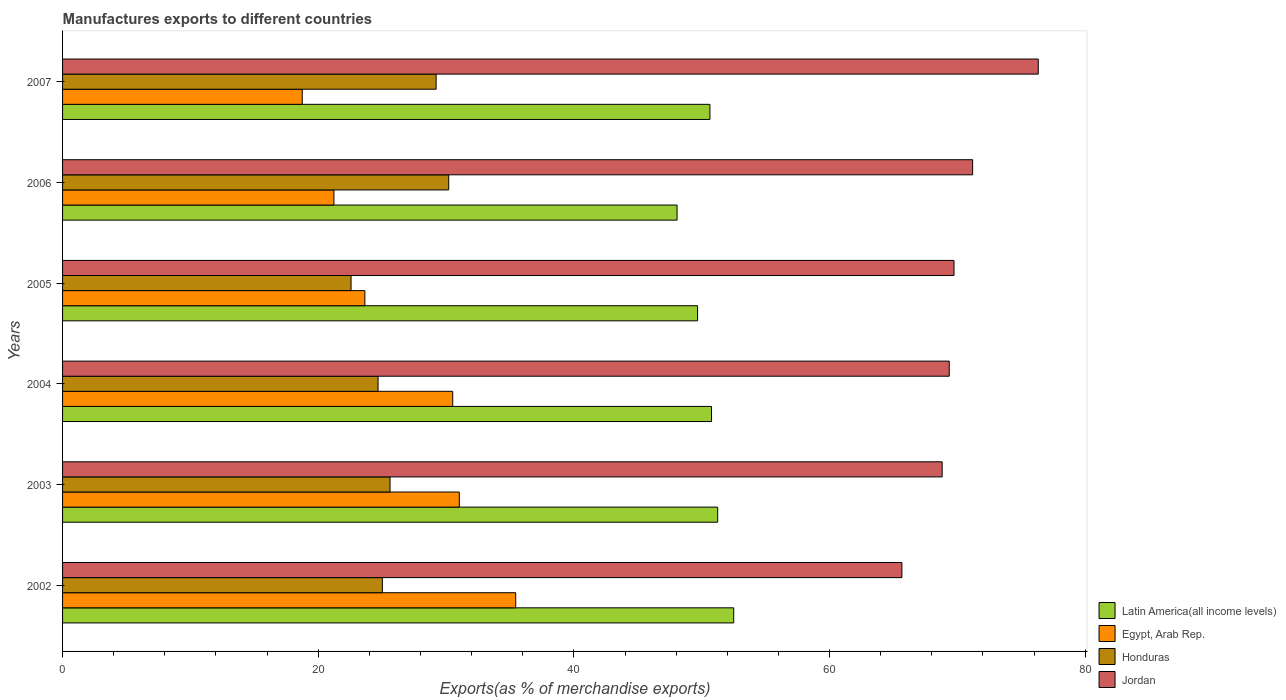Are the number of bars on each tick of the Y-axis equal?
Make the answer very short. Yes. What is the label of the 3rd group of bars from the top?
Provide a succinct answer. 2005. In how many cases, is the number of bars for a given year not equal to the number of legend labels?
Provide a succinct answer. 0. What is the percentage of exports to different countries in Jordan in 2006?
Offer a terse response. 71.19. Across all years, what is the maximum percentage of exports to different countries in Jordan?
Offer a terse response. 76.33. Across all years, what is the minimum percentage of exports to different countries in Latin America(all income levels)?
Your answer should be very brief. 48.07. In which year was the percentage of exports to different countries in Honduras maximum?
Ensure brevity in your answer.  2006. What is the total percentage of exports to different countries in Jordan in the graph?
Make the answer very short. 421.08. What is the difference between the percentage of exports to different countries in Honduras in 2002 and that in 2007?
Ensure brevity in your answer.  -4.2. What is the difference between the percentage of exports to different countries in Egypt, Arab Rep. in 2004 and the percentage of exports to different countries in Honduras in 2006?
Ensure brevity in your answer.  0.31. What is the average percentage of exports to different countries in Jordan per year?
Keep it short and to the point. 70.18. In the year 2007, what is the difference between the percentage of exports to different countries in Honduras and percentage of exports to different countries in Egypt, Arab Rep.?
Provide a succinct answer. 10.47. What is the ratio of the percentage of exports to different countries in Honduras in 2002 to that in 2004?
Make the answer very short. 1.01. What is the difference between the highest and the second highest percentage of exports to different countries in Latin America(all income levels)?
Give a very brief answer. 1.25. What is the difference between the highest and the lowest percentage of exports to different countries in Egypt, Arab Rep.?
Keep it short and to the point. 16.7. Is it the case that in every year, the sum of the percentage of exports to different countries in Honduras and percentage of exports to different countries in Egypt, Arab Rep. is greater than the sum of percentage of exports to different countries in Latin America(all income levels) and percentage of exports to different countries in Jordan?
Offer a very short reply. No. What does the 4th bar from the top in 2003 represents?
Provide a succinct answer. Latin America(all income levels). What does the 3rd bar from the bottom in 2003 represents?
Your response must be concise. Honduras. Is it the case that in every year, the sum of the percentage of exports to different countries in Honduras and percentage of exports to different countries in Egypt, Arab Rep. is greater than the percentage of exports to different countries in Latin America(all income levels)?
Your answer should be very brief. No. How many bars are there?
Your response must be concise. 24. Are the values on the major ticks of X-axis written in scientific E-notation?
Ensure brevity in your answer.  No. Does the graph contain any zero values?
Offer a very short reply. No. Does the graph contain grids?
Provide a short and direct response. No. How are the legend labels stacked?
Ensure brevity in your answer.  Vertical. What is the title of the graph?
Your response must be concise. Manufactures exports to different countries. What is the label or title of the X-axis?
Give a very brief answer. Exports(as % of merchandise exports). What is the Exports(as % of merchandise exports) of Latin America(all income levels) in 2002?
Provide a succinct answer. 52.5. What is the Exports(as % of merchandise exports) of Egypt, Arab Rep. in 2002?
Provide a short and direct response. 35.45. What is the Exports(as % of merchandise exports) of Honduras in 2002?
Your response must be concise. 25.02. What is the Exports(as % of merchandise exports) of Jordan in 2002?
Provide a succinct answer. 65.66. What is the Exports(as % of merchandise exports) in Latin America(all income levels) in 2003?
Your answer should be very brief. 51.25. What is the Exports(as % of merchandise exports) of Egypt, Arab Rep. in 2003?
Your answer should be compact. 31.04. What is the Exports(as % of merchandise exports) in Honduras in 2003?
Offer a terse response. 25.62. What is the Exports(as % of merchandise exports) in Jordan in 2003?
Your response must be concise. 68.81. What is the Exports(as % of merchandise exports) in Latin America(all income levels) in 2004?
Your answer should be compact. 50.77. What is the Exports(as % of merchandise exports) of Egypt, Arab Rep. in 2004?
Your response must be concise. 30.52. What is the Exports(as % of merchandise exports) in Honduras in 2004?
Ensure brevity in your answer.  24.68. What is the Exports(as % of merchandise exports) of Jordan in 2004?
Your answer should be very brief. 69.36. What is the Exports(as % of merchandise exports) in Latin America(all income levels) in 2005?
Offer a terse response. 49.68. What is the Exports(as % of merchandise exports) of Egypt, Arab Rep. in 2005?
Your answer should be compact. 23.65. What is the Exports(as % of merchandise exports) in Honduras in 2005?
Make the answer very short. 22.57. What is the Exports(as % of merchandise exports) of Jordan in 2005?
Provide a short and direct response. 69.73. What is the Exports(as % of merchandise exports) of Latin America(all income levels) in 2006?
Offer a terse response. 48.07. What is the Exports(as % of merchandise exports) in Egypt, Arab Rep. in 2006?
Your answer should be very brief. 21.23. What is the Exports(as % of merchandise exports) in Honduras in 2006?
Ensure brevity in your answer.  30.21. What is the Exports(as % of merchandise exports) in Jordan in 2006?
Keep it short and to the point. 71.19. What is the Exports(as % of merchandise exports) in Latin America(all income levels) in 2007?
Provide a short and direct response. 50.64. What is the Exports(as % of merchandise exports) in Egypt, Arab Rep. in 2007?
Provide a succinct answer. 18.75. What is the Exports(as % of merchandise exports) of Honduras in 2007?
Your answer should be very brief. 29.22. What is the Exports(as % of merchandise exports) in Jordan in 2007?
Offer a very short reply. 76.33. Across all years, what is the maximum Exports(as % of merchandise exports) in Latin America(all income levels)?
Keep it short and to the point. 52.5. Across all years, what is the maximum Exports(as % of merchandise exports) in Egypt, Arab Rep.?
Your answer should be very brief. 35.45. Across all years, what is the maximum Exports(as % of merchandise exports) in Honduras?
Provide a succinct answer. 30.21. Across all years, what is the maximum Exports(as % of merchandise exports) of Jordan?
Provide a succinct answer. 76.33. Across all years, what is the minimum Exports(as % of merchandise exports) of Latin America(all income levels)?
Give a very brief answer. 48.07. Across all years, what is the minimum Exports(as % of merchandise exports) of Egypt, Arab Rep.?
Provide a short and direct response. 18.75. Across all years, what is the minimum Exports(as % of merchandise exports) in Honduras?
Your response must be concise. 22.57. Across all years, what is the minimum Exports(as % of merchandise exports) in Jordan?
Provide a succinct answer. 65.66. What is the total Exports(as % of merchandise exports) in Latin America(all income levels) in the graph?
Ensure brevity in your answer.  302.9. What is the total Exports(as % of merchandise exports) of Egypt, Arab Rep. in the graph?
Keep it short and to the point. 160.63. What is the total Exports(as % of merchandise exports) of Honduras in the graph?
Your answer should be very brief. 157.31. What is the total Exports(as % of merchandise exports) of Jordan in the graph?
Make the answer very short. 421.08. What is the difference between the Exports(as % of merchandise exports) in Latin America(all income levels) in 2002 and that in 2003?
Make the answer very short. 1.25. What is the difference between the Exports(as % of merchandise exports) in Egypt, Arab Rep. in 2002 and that in 2003?
Provide a succinct answer. 4.41. What is the difference between the Exports(as % of merchandise exports) of Honduras in 2002 and that in 2003?
Your answer should be compact. -0.6. What is the difference between the Exports(as % of merchandise exports) of Jordan in 2002 and that in 2003?
Offer a terse response. -3.15. What is the difference between the Exports(as % of merchandise exports) of Latin America(all income levels) in 2002 and that in 2004?
Your response must be concise. 1.74. What is the difference between the Exports(as % of merchandise exports) of Egypt, Arab Rep. in 2002 and that in 2004?
Keep it short and to the point. 4.93. What is the difference between the Exports(as % of merchandise exports) in Honduras in 2002 and that in 2004?
Make the answer very short. 0.34. What is the difference between the Exports(as % of merchandise exports) of Jordan in 2002 and that in 2004?
Give a very brief answer. -3.7. What is the difference between the Exports(as % of merchandise exports) in Latin America(all income levels) in 2002 and that in 2005?
Provide a succinct answer. 2.83. What is the difference between the Exports(as % of merchandise exports) of Egypt, Arab Rep. in 2002 and that in 2005?
Your response must be concise. 11.8. What is the difference between the Exports(as % of merchandise exports) of Honduras in 2002 and that in 2005?
Provide a short and direct response. 2.45. What is the difference between the Exports(as % of merchandise exports) of Jordan in 2002 and that in 2005?
Offer a terse response. -4.08. What is the difference between the Exports(as % of merchandise exports) in Latin America(all income levels) in 2002 and that in 2006?
Give a very brief answer. 4.43. What is the difference between the Exports(as % of merchandise exports) of Egypt, Arab Rep. in 2002 and that in 2006?
Give a very brief answer. 14.22. What is the difference between the Exports(as % of merchandise exports) of Honduras in 2002 and that in 2006?
Ensure brevity in your answer.  -5.19. What is the difference between the Exports(as % of merchandise exports) in Jordan in 2002 and that in 2006?
Offer a very short reply. -5.53. What is the difference between the Exports(as % of merchandise exports) in Latin America(all income levels) in 2002 and that in 2007?
Offer a terse response. 1.86. What is the difference between the Exports(as % of merchandise exports) in Egypt, Arab Rep. in 2002 and that in 2007?
Offer a very short reply. 16.7. What is the difference between the Exports(as % of merchandise exports) of Honduras in 2002 and that in 2007?
Provide a succinct answer. -4.2. What is the difference between the Exports(as % of merchandise exports) of Jordan in 2002 and that in 2007?
Keep it short and to the point. -10.67. What is the difference between the Exports(as % of merchandise exports) of Latin America(all income levels) in 2003 and that in 2004?
Keep it short and to the point. 0.48. What is the difference between the Exports(as % of merchandise exports) in Egypt, Arab Rep. in 2003 and that in 2004?
Offer a very short reply. 0.52. What is the difference between the Exports(as % of merchandise exports) of Honduras in 2003 and that in 2004?
Offer a very short reply. 0.94. What is the difference between the Exports(as % of merchandise exports) of Jordan in 2003 and that in 2004?
Provide a short and direct response. -0.55. What is the difference between the Exports(as % of merchandise exports) of Latin America(all income levels) in 2003 and that in 2005?
Your response must be concise. 1.57. What is the difference between the Exports(as % of merchandise exports) of Egypt, Arab Rep. in 2003 and that in 2005?
Your response must be concise. 7.39. What is the difference between the Exports(as % of merchandise exports) in Honduras in 2003 and that in 2005?
Keep it short and to the point. 3.05. What is the difference between the Exports(as % of merchandise exports) in Jordan in 2003 and that in 2005?
Your response must be concise. -0.93. What is the difference between the Exports(as % of merchandise exports) in Latin America(all income levels) in 2003 and that in 2006?
Keep it short and to the point. 3.18. What is the difference between the Exports(as % of merchandise exports) in Egypt, Arab Rep. in 2003 and that in 2006?
Keep it short and to the point. 9.81. What is the difference between the Exports(as % of merchandise exports) in Honduras in 2003 and that in 2006?
Your answer should be compact. -4.59. What is the difference between the Exports(as % of merchandise exports) in Jordan in 2003 and that in 2006?
Give a very brief answer. -2.38. What is the difference between the Exports(as % of merchandise exports) in Latin America(all income levels) in 2003 and that in 2007?
Provide a succinct answer. 0.61. What is the difference between the Exports(as % of merchandise exports) in Egypt, Arab Rep. in 2003 and that in 2007?
Offer a very short reply. 12.29. What is the difference between the Exports(as % of merchandise exports) of Honduras in 2003 and that in 2007?
Offer a very short reply. -3.6. What is the difference between the Exports(as % of merchandise exports) in Jordan in 2003 and that in 2007?
Ensure brevity in your answer.  -7.52. What is the difference between the Exports(as % of merchandise exports) in Latin America(all income levels) in 2004 and that in 2005?
Offer a terse response. 1.09. What is the difference between the Exports(as % of merchandise exports) of Egypt, Arab Rep. in 2004 and that in 2005?
Your answer should be compact. 6.87. What is the difference between the Exports(as % of merchandise exports) in Honduras in 2004 and that in 2005?
Offer a terse response. 2.11. What is the difference between the Exports(as % of merchandise exports) in Jordan in 2004 and that in 2005?
Offer a very short reply. -0.37. What is the difference between the Exports(as % of merchandise exports) of Latin America(all income levels) in 2004 and that in 2006?
Give a very brief answer. 2.7. What is the difference between the Exports(as % of merchandise exports) in Egypt, Arab Rep. in 2004 and that in 2006?
Provide a succinct answer. 9.29. What is the difference between the Exports(as % of merchandise exports) in Honduras in 2004 and that in 2006?
Your response must be concise. -5.53. What is the difference between the Exports(as % of merchandise exports) in Jordan in 2004 and that in 2006?
Make the answer very short. -1.83. What is the difference between the Exports(as % of merchandise exports) in Latin America(all income levels) in 2004 and that in 2007?
Make the answer very short. 0.13. What is the difference between the Exports(as % of merchandise exports) in Egypt, Arab Rep. in 2004 and that in 2007?
Make the answer very short. 11.77. What is the difference between the Exports(as % of merchandise exports) in Honduras in 2004 and that in 2007?
Keep it short and to the point. -4.54. What is the difference between the Exports(as % of merchandise exports) of Jordan in 2004 and that in 2007?
Keep it short and to the point. -6.96. What is the difference between the Exports(as % of merchandise exports) of Latin America(all income levels) in 2005 and that in 2006?
Keep it short and to the point. 1.6. What is the difference between the Exports(as % of merchandise exports) of Egypt, Arab Rep. in 2005 and that in 2006?
Your answer should be compact. 2.42. What is the difference between the Exports(as % of merchandise exports) in Honduras in 2005 and that in 2006?
Ensure brevity in your answer.  -7.64. What is the difference between the Exports(as % of merchandise exports) in Jordan in 2005 and that in 2006?
Offer a very short reply. -1.46. What is the difference between the Exports(as % of merchandise exports) of Latin America(all income levels) in 2005 and that in 2007?
Your response must be concise. -0.97. What is the difference between the Exports(as % of merchandise exports) in Egypt, Arab Rep. in 2005 and that in 2007?
Offer a very short reply. 4.9. What is the difference between the Exports(as % of merchandise exports) of Honduras in 2005 and that in 2007?
Keep it short and to the point. -6.65. What is the difference between the Exports(as % of merchandise exports) of Jordan in 2005 and that in 2007?
Offer a very short reply. -6.59. What is the difference between the Exports(as % of merchandise exports) of Latin America(all income levels) in 2006 and that in 2007?
Give a very brief answer. -2.57. What is the difference between the Exports(as % of merchandise exports) in Egypt, Arab Rep. in 2006 and that in 2007?
Ensure brevity in your answer.  2.48. What is the difference between the Exports(as % of merchandise exports) in Honduras in 2006 and that in 2007?
Your answer should be compact. 0.99. What is the difference between the Exports(as % of merchandise exports) of Jordan in 2006 and that in 2007?
Your answer should be very brief. -5.13. What is the difference between the Exports(as % of merchandise exports) of Latin America(all income levels) in 2002 and the Exports(as % of merchandise exports) of Egypt, Arab Rep. in 2003?
Your answer should be very brief. 21.47. What is the difference between the Exports(as % of merchandise exports) in Latin America(all income levels) in 2002 and the Exports(as % of merchandise exports) in Honduras in 2003?
Provide a succinct answer. 26.88. What is the difference between the Exports(as % of merchandise exports) in Latin America(all income levels) in 2002 and the Exports(as % of merchandise exports) in Jordan in 2003?
Give a very brief answer. -16.31. What is the difference between the Exports(as % of merchandise exports) in Egypt, Arab Rep. in 2002 and the Exports(as % of merchandise exports) in Honduras in 2003?
Make the answer very short. 9.83. What is the difference between the Exports(as % of merchandise exports) in Egypt, Arab Rep. in 2002 and the Exports(as % of merchandise exports) in Jordan in 2003?
Offer a very short reply. -33.36. What is the difference between the Exports(as % of merchandise exports) in Honduras in 2002 and the Exports(as % of merchandise exports) in Jordan in 2003?
Give a very brief answer. -43.79. What is the difference between the Exports(as % of merchandise exports) of Latin America(all income levels) in 2002 and the Exports(as % of merchandise exports) of Egypt, Arab Rep. in 2004?
Give a very brief answer. 21.98. What is the difference between the Exports(as % of merchandise exports) of Latin America(all income levels) in 2002 and the Exports(as % of merchandise exports) of Honduras in 2004?
Your answer should be compact. 27.82. What is the difference between the Exports(as % of merchandise exports) of Latin America(all income levels) in 2002 and the Exports(as % of merchandise exports) of Jordan in 2004?
Your response must be concise. -16.86. What is the difference between the Exports(as % of merchandise exports) of Egypt, Arab Rep. in 2002 and the Exports(as % of merchandise exports) of Honduras in 2004?
Ensure brevity in your answer.  10.77. What is the difference between the Exports(as % of merchandise exports) of Egypt, Arab Rep. in 2002 and the Exports(as % of merchandise exports) of Jordan in 2004?
Make the answer very short. -33.91. What is the difference between the Exports(as % of merchandise exports) in Honduras in 2002 and the Exports(as % of merchandise exports) in Jordan in 2004?
Ensure brevity in your answer.  -44.34. What is the difference between the Exports(as % of merchandise exports) in Latin America(all income levels) in 2002 and the Exports(as % of merchandise exports) in Egypt, Arab Rep. in 2005?
Ensure brevity in your answer.  28.85. What is the difference between the Exports(as % of merchandise exports) of Latin America(all income levels) in 2002 and the Exports(as % of merchandise exports) of Honduras in 2005?
Make the answer very short. 29.93. What is the difference between the Exports(as % of merchandise exports) in Latin America(all income levels) in 2002 and the Exports(as % of merchandise exports) in Jordan in 2005?
Give a very brief answer. -17.23. What is the difference between the Exports(as % of merchandise exports) of Egypt, Arab Rep. in 2002 and the Exports(as % of merchandise exports) of Honduras in 2005?
Give a very brief answer. 12.88. What is the difference between the Exports(as % of merchandise exports) of Egypt, Arab Rep. in 2002 and the Exports(as % of merchandise exports) of Jordan in 2005?
Your response must be concise. -34.29. What is the difference between the Exports(as % of merchandise exports) of Honduras in 2002 and the Exports(as % of merchandise exports) of Jordan in 2005?
Provide a succinct answer. -44.72. What is the difference between the Exports(as % of merchandise exports) in Latin America(all income levels) in 2002 and the Exports(as % of merchandise exports) in Egypt, Arab Rep. in 2006?
Make the answer very short. 31.28. What is the difference between the Exports(as % of merchandise exports) in Latin America(all income levels) in 2002 and the Exports(as % of merchandise exports) in Honduras in 2006?
Keep it short and to the point. 22.3. What is the difference between the Exports(as % of merchandise exports) of Latin America(all income levels) in 2002 and the Exports(as % of merchandise exports) of Jordan in 2006?
Make the answer very short. -18.69. What is the difference between the Exports(as % of merchandise exports) in Egypt, Arab Rep. in 2002 and the Exports(as % of merchandise exports) in Honduras in 2006?
Give a very brief answer. 5.24. What is the difference between the Exports(as % of merchandise exports) in Egypt, Arab Rep. in 2002 and the Exports(as % of merchandise exports) in Jordan in 2006?
Provide a short and direct response. -35.74. What is the difference between the Exports(as % of merchandise exports) of Honduras in 2002 and the Exports(as % of merchandise exports) of Jordan in 2006?
Give a very brief answer. -46.17. What is the difference between the Exports(as % of merchandise exports) of Latin America(all income levels) in 2002 and the Exports(as % of merchandise exports) of Egypt, Arab Rep. in 2007?
Offer a terse response. 33.75. What is the difference between the Exports(as % of merchandise exports) of Latin America(all income levels) in 2002 and the Exports(as % of merchandise exports) of Honduras in 2007?
Ensure brevity in your answer.  23.28. What is the difference between the Exports(as % of merchandise exports) in Latin America(all income levels) in 2002 and the Exports(as % of merchandise exports) in Jordan in 2007?
Your answer should be very brief. -23.82. What is the difference between the Exports(as % of merchandise exports) in Egypt, Arab Rep. in 2002 and the Exports(as % of merchandise exports) in Honduras in 2007?
Provide a short and direct response. 6.23. What is the difference between the Exports(as % of merchandise exports) of Egypt, Arab Rep. in 2002 and the Exports(as % of merchandise exports) of Jordan in 2007?
Offer a very short reply. -40.88. What is the difference between the Exports(as % of merchandise exports) of Honduras in 2002 and the Exports(as % of merchandise exports) of Jordan in 2007?
Offer a very short reply. -51.31. What is the difference between the Exports(as % of merchandise exports) of Latin America(all income levels) in 2003 and the Exports(as % of merchandise exports) of Egypt, Arab Rep. in 2004?
Provide a short and direct response. 20.73. What is the difference between the Exports(as % of merchandise exports) in Latin America(all income levels) in 2003 and the Exports(as % of merchandise exports) in Honduras in 2004?
Provide a succinct answer. 26.57. What is the difference between the Exports(as % of merchandise exports) in Latin America(all income levels) in 2003 and the Exports(as % of merchandise exports) in Jordan in 2004?
Your answer should be very brief. -18.11. What is the difference between the Exports(as % of merchandise exports) in Egypt, Arab Rep. in 2003 and the Exports(as % of merchandise exports) in Honduras in 2004?
Provide a short and direct response. 6.36. What is the difference between the Exports(as % of merchandise exports) of Egypt, Arab Rep. in 2003 and the Exports(as % of merchandise exports) of Jordan in 2004?
Your answer should be very brief. -38.32. What is the difference between the Exports(as % of merchandise exports) of Honduras in 2003 and the Exports(as % of merchandise exports) of Jordan in 2004?
Ensure brevity in your answer.  -43.74. What is the difference between the Exports(as % of merchandise exports) of Latin America(all income levels) in 2003 and the Exports(as % of merchandise exports) of Egypt, Arab Rep. in 2005?
Give a very brief answer. 27.6. What is the difference between the Exports(as % of merchandise exports) in Latin America(all income levels) in 2003 and the Exports(as % of merchandise exports) in Honduras in 2005?
Your response must be concise. 28.68. What is the difference between the Exports(as % of merchandise exports) in Latin America(all income levels) in 2003 and the Exports(as % of merchandise exports) in Jordan in 2005?
Offer a very short reply. -18.49. What is the difference between the Exports(as % of merchandise exports) in Egypt, Arab Rep. in 2003 and the Exports(as % of merchandise exports) in Honduras in 2005?
Your response must be concise. 8.47. What is the difference between the Exports(as % of merchandise exports) of Egypt, Arab Rep. in 2003 and the Exports(as % of merchandise exports) of Jordan in 2005?
Provide a succinct answer. -38.7. What is the difference between the Exports(as % of merchandise exports) of Honduras in 2003 and the Exports(as % of merchandise exports) of Jordan in 2005?
Provide a short and direct response. -44.12. What is the difference between the Exports(as % of merchandise exports) in Latin America(all income levels) in 2003 and the Exports(as % of merchandise exports) in Egypt, Arab Rep. in 2006?
Give a very brief answer. 30.02. What is the difference between the Exports(as % of merchandise exports) in Latin America(all income levels) in 2003 and the Exports(as % of merchandise exports) in Honduras in 2006?
Give a very brief answer. 21.04. What is the difference between the Exports(as % of merchandise exports) in Latin America(all income levels) in 2003 and the Exports(as % of merchandise exports) in Jordan in 2006?
Offer a very short reply. -19.94. What is the difference between the Exports(as % of merchandise exports) in Egypt, Arab Rep. in 2003 and the Exports(as % of merchandise exports) in Honduras in 2006?
Make the answer very short. 0.83. What is the difference between the Exports(as % of merchandise exports) in Egypt, Arab Rep. in 2003 and the Exports(as % of merchandise exports) in Jordan in 2006?
Ensure brevity in your answer.  -40.15. What is the difference between the Exports(as % of merchandise exports) in Honduras in 2003 and the Exports(as % of merchandise exports) in Jordan in 2006?
Make the answer very short. -45.57. What is the difference between the Exports(as % of merchandise exports) of Latin America(all income levels) in 2003 and the Exports(as % of merchandise exports) of Egypt, Arab Rep. in 2007?
Ensure brevity in your answer.  32.5. What is the difference between the Exports(as % of merchandise exports) in Latin America(all income levels) in 2003 and the Exports(as % of merchandise exports) in Honduras in 2007?
Make the answer very short. 22.03. What is the difference between the Exports(as % of merchandise exports) in Latin America(all income levels) in 2003 and the Exports(as % of merchandise exports) in Jordan in 2007?
Your answer should be very brief. -25.08. What is the difference between the Exports(as % of merchandise exports) in Egypt, Arab Rep. in 2003 and the Exports(as % of merchandise exports) in Honduras in 2007?
Provide a short and direct response. 1.81. What is the difference between the Exports(as % of merchandise exports) of Egypt, Arab Rep. in 2003 and the Exports(as % of merchandise exports) of Jordan in 2007?
Provide a short and direct response. -45.29. What is the difference between the Exports(as % of merchandise exports) in Honduras in 2003 and the Exports(as % of merchandise exports) in Jordan in 2007?
Provide a short and direct response. -50.71. What is the difference between the Exports(as % of merchandise exports) in Latin America(all income levels) in 2004 and the Exports(as % of merchandise exports) in Egypt, Arab Rep. in 2005?
Offer a terse response. 27.12. What is the difference between the Exports(as % of merchandise exports) in Latin America(all income levels) in 2004 and the Exports(as % of merchandise exports) in Honduras in 2005?
Your answer should be very brief. 28.2. What is the difference between the Exports(as % of merchandise exports) in Latin America(all income levels) in 2004 and the Exports(as % of merchandise exports) in Jordan in 2005?
Offer a terse response. -18.97. What is the difference between the Exports(as % of merchandise exports) of Egypt, Arab Rep. in 2004 and the Exports(as % of merchandise exports) of Honduras in 2005?
Your answer should be compact. 7.95. What is the difference between the Exports(as % of merchandise exports) of Egypt, Arab Rep. in 2004 and the Exports(as % of merchandise exports) of Jordan in 2005?
Offer a terse response. -39.21. What is the difference between the Exports(as % of merchandise exports) of Honduras in 2004 and the Exports(as % of merchandise exports) of Jordan in 2005?
Ensure brevity in your answer.  -45.05. What is the difference between the Exports(as % of merchandise exports) of Latin America(all income levels) in 2004 and the Exports(as % of merchandise exports) of Egypt, Arab Rep. in 2006?
Your response must be concise. 29.54. What is the difference between the Exports(as % of merchandise exports) of Latin America(all income levels) in 2004 and the Exports(as % of merchandise exports) of Honduras in 2006?
Your response must be concise. 20.56. What is the difference between the Exports(as % of merchandise exports) in Latin America(all income levels) in 2004 and the Exports(as % of merchandise exports) in Jordan in 2006?
Offer a terse response. -20.42. What is the difference between the Exports(as % of merchandise exports) of Egypt, Arab Rep. in 2004 and the Exports(as % of merchandise exports) of Honduras in 2006?
Make the answer very short. 0.31. What is the difference between the Exports(as % of merchandise exports) in Egypt, Arab Rep. in 2004 and the Exports(as % of merchandise exports) in Jordan in 2006?
Provide a short and direct response. -40.67. What is the difference between the Exports(as % of merchandise exports) in Honduras in 2004 and the Exports(as % of merchandise exports) in Jordan in 2006?
Provide a short and direct response. -46.51. What is the difference between the Exports(as % of merchandise exports) of Latin America(all income levels) in 2004 and the Exports(as % of merchandise exports) of Egypt, Arab Rep. in 2007?
Keep it short and to the point. 32.02. What is the difference between the Exports(as % of merchandise exports) of Latin America(all income levels) in 2004 and the Exports(as % of merchandise exports) of Honduras in 2007?
Offer a very short reply. 21.55. What is the difference between the Exports(as % of merchandise exports) of Latin America(all income levels) in 2004 and the Exports(as % of merchandise exports) of Jordan in 2007?
Make the answer very short. -25.56. What is the difference between the Exports(as % of merchandise exports) of Egypt, Arab Rep. in 2004 and the Exports(as % of merchandise exports) of Honduras in 2007?
Give a very brief answer. 1.3. What is the difference between the Exports(as % of merchandise exports) in Egypt, Arab Rep. in 2004 and the Exports(as % of merchandise exports) in Jordan in 2007?
Your answer should be compact. -45.8. What is the difference between the Exports(as % of merchandise exports) of Honduras in 2004 and the Exports(as % of merchandise exports) of Jordan in 2007?
Make the answer very short. -51.64. What is the difference between the Exports(as % of merchandise exports) in Latin America(all income levels) in 2005 and the Exports(as % of merchandise exports) in Egypt, Arab Rep. in 2006?
Ensure brevity in your answer.  28.45. What is the difference between the Exports(as % of merchandise exports) in Latin America(all income levels) in 2005 and the Exports(as % of merchandise exports) in Honduras in 2006?
Your answer should be very brief. 19.47. What is the difference between the Exports(as % of merchandise exports) of Latin America(all income levels) in 2005 and the Exports(as % of merchandise exports) of Jordan in 2006?
Offer a very short reply. -21.52. What is the difference between the Exports(as % of merchandise exports) of Egypt, Arab Rep. in 2005 and the Exports(as % of merchandise exports) of Honduras in 2006?
Provide a succinct answer. -6.56. What is the difference between the Exports(as % of merchandise exports) in Egypt, Arab Rep. in 2005 and the Exports(as % of merchandise exports) in Jordan in 2006?
Make the answer very short. -47.54. What is the difference between the Exports(as % of merchandise exports) of Honduras in 2005 and the Exports(as % of merchandise exports) of Jordan in 2006?
Offer a very short reply. -48.62. What is the difference between the Exports(as % of merchandise exports) in Latin America(all income levels) in 2005 and the Exports(as % of merchandise exports) in Egypt, Arab Rep. in 2007?
Provide a short and direct response. 30.93. What is the difference between the Exports(as % of merchandise exports) in Latin America(all income levels) in 2005 and the Exports(as % of merchandise exports) in Honduras in 2007?
Make the answer very short. 20.45. What is the difference between the Exports(as % of merchandise exports) of Latin America(all income levels) in 2005 and the Exports(as % of merchandise exports) of Jordan in 2007?
Your response must be concise. -26.65. What is the difference between the Exports(as % of merchandise exports) in Egypt, Arab Rep. in 2005 and the Exports(as % of merchandise exports) in Honduras in 2007?
Offer a very short reply. -5.57. What is the difference between the Exports(as % of merchandise exports) of Egypt, Arab Rep. in 2005 and the Exports(as % of merchandise exports) of Jordan in 2007?
Provide a succinct answer. -52.68. What is the difference between the Exports(as % of merchandise exports) in Honduras in 2005 and the Exports(as % of merchandise exports) in Jordan in 2007?
Keep it short and to the point. -53.76. What is the difference between the Exports(as % of merchandise exports) in Latin America(all income levels) in 2006 and the Exports(as % of merchandise exports) in Egypt, Arab Rep. in 2007?
Make the answer very short. 29.32. What is the difference between the Exports(as % of merchandise exports) in Latin America(all income levels) in 2006 and the Exports(as % of merchandise exports) in Honduras in 2007?
Make the answer very short. 18.85. What is the difference between the Exports(as % of merchandise exports) in Latin America(all income levels) in 2006 and the Exports(as % of merchandise exports) in Jordan in 2007?
Your answer should be very brief. -28.25. What is the difference between the Exports(as % of merchandise exports) in Egypt, Arab Rep. in 2006 and the Exports(as % of merchandise exports) in Honduras in 2007?
Ensure brevity in your answer.  -8. What is the difference between the Exports(as % of merchandise exports) in Egypt, Arab Rep. in 2006 and the Exports(as % of merchandise exports) in Jordan in 2007?
Make the answer very short. -55.1. What is the difference between the Exports(as % of merchandise exports) of Honduras in 2006 and the Exports(as % of merchandise exports) of Jordan in 2007?
Ensure brevity in your answer.  -46.12. What is the average Exports(as % of merchandise exports) of Latin America(all income levels) per year?
Offer a very short reply. 50.48. What is the average Exports(as % of merchandise exports) of Egypt, Arab Rep. per year?
Keep it short and to the point. 26.77. What is the average Exports(as % of merchandise exports) in Honduras per year?
Offer a terse response. 26.22. What is the average Exports(as % of merchandise exports) in Jordan per year?
Your answer should be compact. 70.18. In the year 2002, what is the difference between the Exports(as % of merchandise exports) in Latin America(all income levels) and Exports(as % of merchandise exports) in Egypt, Arab Rep.?
Offer a terse response. 17.05. In the year 2002, what is the difference between the Exports(as % of merchandise exports) in Latin America(all income levels) and Exports(as % of merchandise exports) in Honduras?
Your answer should be compact. 27.48. In the year 2002, what is the difference between the Exports(as % of merchandise exports) in Latin America(all income levels) and Exports(as % of merchandise exports) in Jordan?
Offer a terse response. -13.16. In the year 2002, what is the difference between the Exports(as % of merchandise exports) in Egypt, Arab Rep. and Exports(as % of merchandise exports) in Honduras?
Your response must be concise. 10.43. In the year 2002, what is the difference between the Exports(as % of merchandise exports) in Egypt, Arab Rep. and Exports(as % of merchandise exports) in Jordan?
Give a very brief answer. -30.21. In the year 2002, what is the difference between the Exports(as % of merchandise exports) in Honduras and Exports(as % of merchandise exports) in Jordan?
Ensure brevity in your answer.  -40.64. In the year 2003, what is the difference between the Exports(as % of merchandise exports) of Latin America(all income levels) and Exports(as % of merchandise exports) of Egypt, Arab Rep.?
Make the answer very short. 20.21. In the year 2003, what is the difference between the Exports(as % of merchandise exports) of Latin America(all income levels) and Exports(as % of merchandise exports) of Honduras?
Offer a terse response. 25.63. In the year 2003, what is the difference between the Exports(as % of merchandise exports) of Latin America(all income levels) and Exports(as % of merchandise exports) of Jordan?
Offer a very short reply. -17.56. In the year 2003, what is the difference between the Exports(as % of merchandise exports) in Egypt, Arab Rep. and Exports(as % of merchandise exports) in Honduras?
Make the answer very short. 5.42. In the year 2003, what is the difference between the Exports(as % of merchandise exports) in Egypt, Arab Rep. and Exports(as % of merchandise exports) in Jordan?
Offer a terse response. -37.77. In the year 2003, what is the difference between the Exports(as % of merchandise exports) in Honduras and Exports(as % of merchandise exports) in Jordan?
Give a very brief answer. -43.19. In the year 2004, what is the difference between the Exports(as % of merchandise exports) in Latin America(all income levels) and Exports(as % of merchandise exports) in Egypt, Arab Rep.?
Offer a terse response. 20.25. In the year 2004, what is the difference between the Exports(as % of merchandise exports) in Latin America(all income levels) and Exports(as % of merchandise exports) in Honduras?
Ensure brevity in your answer.  26.09. In the year 2004, what is the difference between the Exports(as % of merchandise exports) in Latin America(all income levels) and Exports(as % of merchandise exports) in Jordan?
Provide a succinct answer. -18.59. In the year 2004, what is the difference between the Exports(as % of merchandise exports) in Egypt, Arab Rep. and Exports(as % of merchandise exports) in Honduras?
Your response must be concise. 5.84. In the year 2004, what is the difference between the Exports(as % of merchandise exports) in Egypt, Arab Rep. and Exports(as % of merchandise exports) in Jordan?
Give a very brief answer. -38.84. In the year 2004, what is the difference between the Exports(as % of merchandise exports) in Honduras and Exports(as % of merchandise exports) in Jordan?
Make the answer very short. -44.68. In the year 2005, what is the difference between the Exports(as % of merchandise exports) in Latin America(all income levels) and Exports(as % of merchandise exports) in Egypt, Arab Rep.?
Ensure brevity in your answer.  26.03. In the year 2005, what is the difference between the Exports(as % of merchandise exports) of Latin America(all income levels) and Exports(as % of merchandise exports) of Honduras?
Your answer should be compact. 27.11. In the year 2005, what is the difference between the Exports(as % of merchandise exports) of Latin America(all income levels) and Exports(as % of merchandise exports) of Jordan?
Provide a succinct answer. -20.06. In the year 2005, what is the difference between the Exports(as % of merchandise exports) of Egypt, Arab Rep. and Exports(as % of merchandise exports) of Honduras?
Ensure brevity in your answer.  1.08. In the year 2005, what is the difference between the Exports(as % of merchandise exports) of Egypt, Arab Rep. and Exports(as % of merchandise exports) of Jordan?
Provide a succinct answer. -46.09. In the year 2005, what is the difference between the Exports(as % of merchandise exports) of Honduras and Exports(as % of merchandise exports) of Jordan?
Offer a terse response. -47.17. In the year 2006, what is the difference between the Exports(as % of merchandise exports) in Latin America(all income levels) and Exports(as % of merchandise exports) in Egypt, Arab Rep.?
Your answer should be very brief. 26.84. In the year 2006, what is the difference between the Exports(as % of merchandise exports) of Latin America(all income levels) and Exports(as % of merchandise exports) of Honduras?
Your response must be concise. 17.86. In the year 2006, what is the difference between the Exports(as % of merchandise exports) in Latin America(all income levels) and Exports(as % of merchandise exports) in Jordan?
Keep it short and to the point. -23.12. In the year 2006, what is the difference between the Exports(as % of merchandise exports) in Egypt, Arab Rep. and Exports(as % of merchandise exports) in Honduras?
Ensure brevity in your answer.  -8.98. In the year 2006, what is the difference between the Exports(as % of merchandise exports) in Egypt, Arab Rep. and Exports(as % of merchandise exports) in Jordan?
Provide a succinct answer. -49.96. In the year 2006, what is the difference between the Exports(as % of merchandise exports) in Honduras and Exports(as % of merchandise exports) in Jordan?
Provide a short and direct response. -40.98. In the year 2007, what is the difference between the Exports(as % of merchandise exports) of Latin America(all income levels) and Exports(as % of merchandise exports) of Egypt, Arab Rep.?
Give a very brief answer. 31.89. In the year 2007, what is the difference between the Exports(as % of merchandise exports) in Latin America(all income levels) and Exports(as % of merchandise exports) in Honduras?
Ensure brevity in your answer.  21.42. In the year 2007, what is the difference between the Exports(as % of merchandise exports) in Latin America(all income levels) and Exports(as % of merchandise exports) in Jordan?
Offer a very short reply. -25.68. In the year 2007, what is the difference between the Exports(as % of merchandise exports) of Egypt, Arab Rep. and Exports(as % of merchandise exports) of Honduras?
Ensure brevity in your answer.  -10.47. In the year 2007, what is the difference between the Exports(as % of merchandise exports) of Egypt, Arab Rep. and Exports(as % of merchandise exports) of Jordan?
Offer a terse response. -57.58. In the year 2007, what is the difference between the Exports(as % of merchandise exports) of Honduras and Exports(as % of merchandise exports) of Jordan?
Offer a very short reply. -47.1. What is the ratio of the Exports(as % of merchandise exports) of Latin America(all income levels) in 2002 to that in 2003?
Your answer should be compact. 1.02. What is the ratio of the Exports(as % of merchandise exports) in Egypt, Arab Rep. in 2002 to that in 2003?
Offer a very short reply. 1.14. What is the ratio of the Exports(as % of merchandise exports) in Honduras in 2002 to that in 2003?
Provide a short and direct response. 0.98. What is the ratio of the Exports(as % of merchandise exports) in Jordan in 2002 to that in 2003?
Make the answer very short. 0.95. What is the ratio of the Exports(as % of merchandise exports) of Latin America(all income levels) in 2002 to that in 2004?
Provide a succinct answer. 1.03. What is the ratio of the Exports(as % of merchandise exports) of Egypt, Arab Rep. in 2002 to that in 2004?
Offer a very short reply. 1.16. What is the ratio of the Exports(as % of merchandise exports) in Honduras in 2002 to that in 2004?
Ensure brevity in your answer.  1.01. What is the ratio of the Exports(as % of merchandise exports) in Jordan in 2002 to that in 2004?
Offer a terse response. 0.95. What is the ratio of the Exports(as % of merchandise exports) of Latin America(all income levels) in 2002 to that in 2005?
Ensure brevity in your answer.  1.06. What is the ratio of the Exports(as % of merchandise exports) in Egypt, Arab Rep. in 2002 to that in 2005?
Give a very brief answer. 1.5. What is the ratio of the Exports(as % of merchandise exports) in Honduras in 2002 to that in 2005?
Give a very brief answer. 1.11. What is the ratio of the Exports(as % of merchandise exports) of Jordan in 2002 to that in 2005?
Your answer should be very brief. 0.94. What is the ratio of the Exports(as % of merchandise exports) in Latin America(all income levels) in 2002 to that in 2006?
Keep it short and to the point. 1.09. What is the ratio of the Exports(as % of merchandise exports) of Egypt, Arab Rep. in 2002 to that in 2006?
Provide a succinct answer. 1.67. What is the ratio of the Exports(as % of merchandise exports) of Honduras in 2002 to that in 2006?
Keep it short and to the point. 0.83. What is the ratio of the Exports(as % of merchandise exports) in Jordan in 2002 to that in 2006?
Give a very brief answer. 0.92. What is the ratio of the Exports(as % of merchandise exports) in Latin America(all income levels) in 2002 to that in 2007?
Offer a very short reply. 1.04. What is the ratio of the Exports(as % of merchandise exports) of Egypt, Arab Rep. in 2002 to that in 2007?
Give a very brief answer. 1.89. What is the ratio of the Exports(as % of merchandise exports) in Honduras in 2002 to that in 2007?
Provide a short and direct response. 0.86. What is the ratio of the Exports(as % of merchandise exports) in Jordan in 2002 to that in 2007?
Your answer should be compact. 0.86. What is the ratio of the Exports(as % of merchandise exports) of Latin America(all income levels) in 2003 to that in 2004?
Your response must be concise. 1.01. What is the ratio of the Exports(as % of merchandise exports) in Egypt, Arab Rep. in 2003 to that in 2004?
Your response must be concise. 1.02. What is the ratio of the Exports(as % of merchandise exports) of Honduras in 2003 to that in 2004?
Keep it short and to the point. 1.04. What is the ratio of the Exports(as % of merchandise exports) in Latin America(all income levels) in 2003 to that in 2005?
Keep it short and to the point. 1.03. What is the ratio of the Exports(as % of merchandise exports) of Egypt, Arab Rep. in 2003 to that in 2005?
Your answer should be very brief. 1.31. What is the ratio of the Exports(as % of merchandise exports) of Honduras in 2003 to that in 2005?
Provide a succinct answer. 1.14. What is the ratio of the Exports(as % of merchandise exports) of Jordan in 2003 to that in 2005?
Your answer should be very brief. 0.99. What is the ratio of the Exports(as % of merchandise exports) of Latin America(all income levels) in 2003 to that in 2006?
Make the answer very short. 1.07. What is the ratio of the Exports(as % of merchandise exports) of Egypt, Arab Rep. in 2003 to that in 2006?
Provide a short and direct response. 1.46. What is the ratio of the Exports(as % of merchandise exports) of Honduras in 2003 to that in 2006?
Provide a succinct answer. 0.85. What is the ratio of the Exports(as % of merchandise exports) in Jordan in 2003 to that in 2006?
Offer a terse response. 0.97. What is the ratio of the Exports(as % of merchandise exports) of Egypt, Arab Rep. in 2003 to that in 2007?
Ensure brevity in your answer.  1.66. What is the ratio of the Exports(as % of merchandise exports) of Honduras in 2003 to that in 2007?
Provide a short and direct response. 0.88. What is the ratio of the Exports(as % of merchandise exports) of Jordan in 2003 to that in 2007?
Provide a succinct answer. 0.9. What is the ratio of the Exports(as % of merchandise exports) in Latin America(all income levels) in 2004 to that in 2005?
Keep it short and to the point. 1.02. What is the ratio of the Exports(as % of merchandise exports) in Egypt, Arab Rep. in 2004 to that in 2005?
Offer a very short reply. 1.29. What is the ratio of the Exports(as % of merchandise exports) of Honduras in 2004 to that in 2005?
Give a very brief answer. 1.09. What is the ratio of the Exports(as % of merchandise exports) in Jordan in 2004 to that in 2005?
Provide a short and direct response. 0.99. What is the ratio of the Exports(as % of merchandise exports) of Latin America(all income levels) in 2004 to that in 2006?
Provide a succinct answer. 1.06. What is the ratio of the Exports(as % of merchandise exports) of Egypt, Arab Rep. in 2004 to that in 2006?
Your response must be concise. 1.44. What is the ratio of the Exports(as % of merchandise exports) in Honduras in 2004 to that in 2006?
Your answer should be compact. 0.82. What is the ratio of the Exports(as % of merchandise exports) in Jordan in 2004 to that in 2006?
Your answer should be very brief. 0.97. What is the ratio of the Exports(as % of merchandise exports) in Latin America(all income levels) in 2004 to that in 2007?
Offer a very short reply. 1. What is the ratio of the Exports(as % of merchandise exports) in Egypt, Arab Rep. in 2004 to that in 2007?
Your answer should be compact. 1.63. What is the ratio of the Exports(as % of merchandise exports) of Honduras in 2004 to that in 2007?
Provide a succinct answer. 0.84. What is the ratio of the Exports(as % of merchandise exports) in Jordan in 2004 to that in 2007?
Provide a short and direct response. 0.91. What is the ratio of the Exports(as % of merchandise exports) in Latin America(all income levels) in 2005 to that in 2006?
Offer a terse response. 1.03. What is the ratio of the Exports(as % of merchandise exports) of Egypt, Arab Rep. in 2005 to that in 2006?
Make the answer very short. 1.11. What is the ratio of the Exports(as % of merchandise exports) in Honduras in 2005 to that in 2006?
Your answer should be compact. 0.75. What is the ratio of the Exports(as % of merchandise exports) in Jordan in 2005 to that in 2006?
Ensure brevity in your answer.  0.98. What is the ratio of the Exports(as % of merchandise exports) of Latin America(all income levels) in 2005 to that in 2007?
Provide a succinct answer. 0.98. What is the ratio of the Exports(as % of merchandise exports) of Egypt, Arab Rep. in 2005 to that in 2007?
Provide a succinct answer. 1.26. What is the ratio of the Exports(as % of merchandise exports) of Honduras in 2005 to that in 2007?
Your response must be concise. 0.77. What is the ratio of the Exports(as % of merchandise exports) of Jordan in 2005 to that in 2007?
Provide a short and direct response. 0.91. What is the ratio of the Exports(as % of merchandise exports) in Latin America(all income levels) in 2006 to that in 2007?
Provide a short and direct response. 0.95. What is the ratio of the Exports(as % of merchandise exports) of Egypt, Arab Rep. in 2006 to that in 2007?
Your answer should be compact. 1.13. What is the ratio of the Exports(as % of merchandise exports) of Honduras in 2006 to that in 2007?
Ensure brevity in your answer.  1.03. What is the ratio of the Exports(as % of merchandise exports) of Jordan in 2006 to that in 2007?
Your response must be concise. 0.93. What is the difference between the highest and the second highest Exports(as % of merchandise exports) of Latin America(all income levels)?
Your answer should be very brief. 1.25. What is the difference between the highest and the second highest Exports(as % of merchandise exports) of Egypt, Arab Rep.?
Your answer should be compact. 4.41. What is the difference between the highest and the second highest Exports(as % of merchandise exports) in Honduras?
Your response must be concise. 0.99. What is the difference between the highest and the second highest Exports(as % of merchandise exports) in Jordan?
Offer a terse response. 5.13. What is the difference between the highest and the lowest Exports(as % of merchandise exports) of Latin America(all income levels)?
Ensure brevity in your answer.  4.43. What is the difference between the highest and the lowest Exports(as % of merchandise exports) of Egypt, Arab Rep.?
Make the answer very short. 16.7. What is the difference between the highest and the lowest Exports(as % of merchandise exports) in Honduras?
Make the answer very short. 7.64. What is the difference between the highest and the lowest Exports(as % of merchandise exports) of Jordan?
Your answer should be very brief. 10.67. 